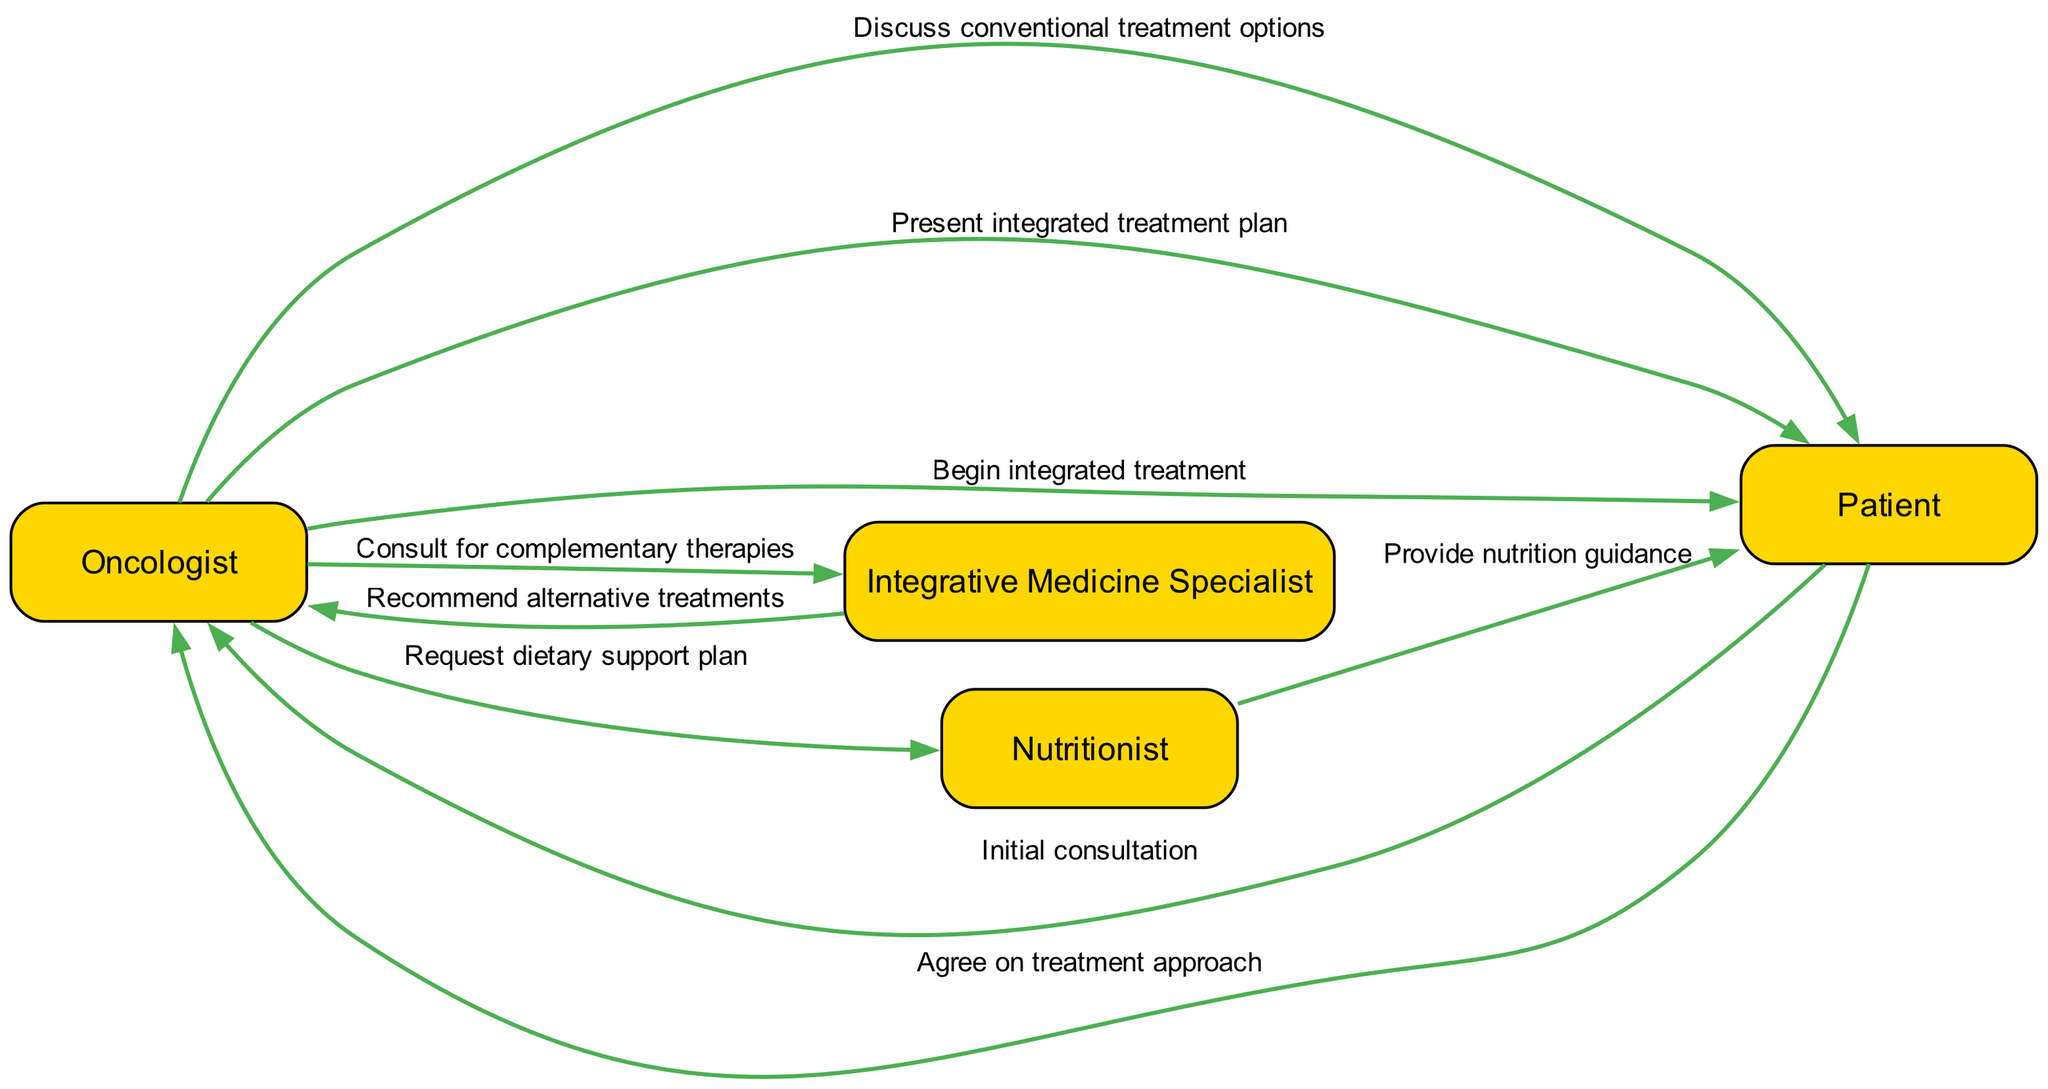What is the first action in the patient consultation process? The first action in the sequence is from the Patient to the Oncologist, labeled as "Initial consultation." This indicates that the patient initiates the consultation.
Answer: Initial consultation How many actors are involved in the diagram? The diagram contains four actors: Oncologist, Patient, Integrative Medicine Specialist, and Nutritionist. By counting each uniquely defined actor, we arrive at the total.
Answer: 4 What action does the Oncologist take after consulting the Integrative Medicine Specialist? After consulting the Integrative Medicine Specialist, the Oncologist receives a recommendation for alternative treatments. This is indicated by an action sequence from the Integrative Medicine Specialist back to the Oncologist.
Answer: Recommend alternative treatments Which actor provides nutrition guidance to the Patient? The Nutritionist is responsible for providing nutrition guidance to the Patient, as shown by the action directed from the Nutritionist to the Patient.
Answer: Nutritionist What is the final action taken by the Oncologist in the consultation process? The final action taken by the Oncologist in this consultation process is to "Begin integrated treatment," indicating the transition into the treatment phase.
Answer: Begin integrated treatment Which actor does the Oncologist consult for complementary therapies? The Oncologist consults the Integrative Medicine Specialist for complementary therapies, as indicated by the directional action in the sequence from Oncologist to Integrative Medicine Specialist.
Answer: Integrative Medicine Specialist What action does the Patient take after the Oncologist presents the integrated treatment plan? After the Oncologist presents the integrated treatment plan, the Patient agrees on the treatment approach; this agreement shows collaboration and mutual decision-making.
Answer: Agree on treatment approach How many actions involve the Oncologist? The Oncologist is involved in five distinct actions within the diagram, marked by the sequences initiated by or directed to the Oncologist, indicating a central role in the process.
Answer: 5 What is the purpose of the action from the Oncologist to the Nutritionist? The purpose of this action is to request a dietary support plan, highlighting the integrative approach that includes nutritional guidance as part of the treatment plan.
Answer: Request dietary support plan 